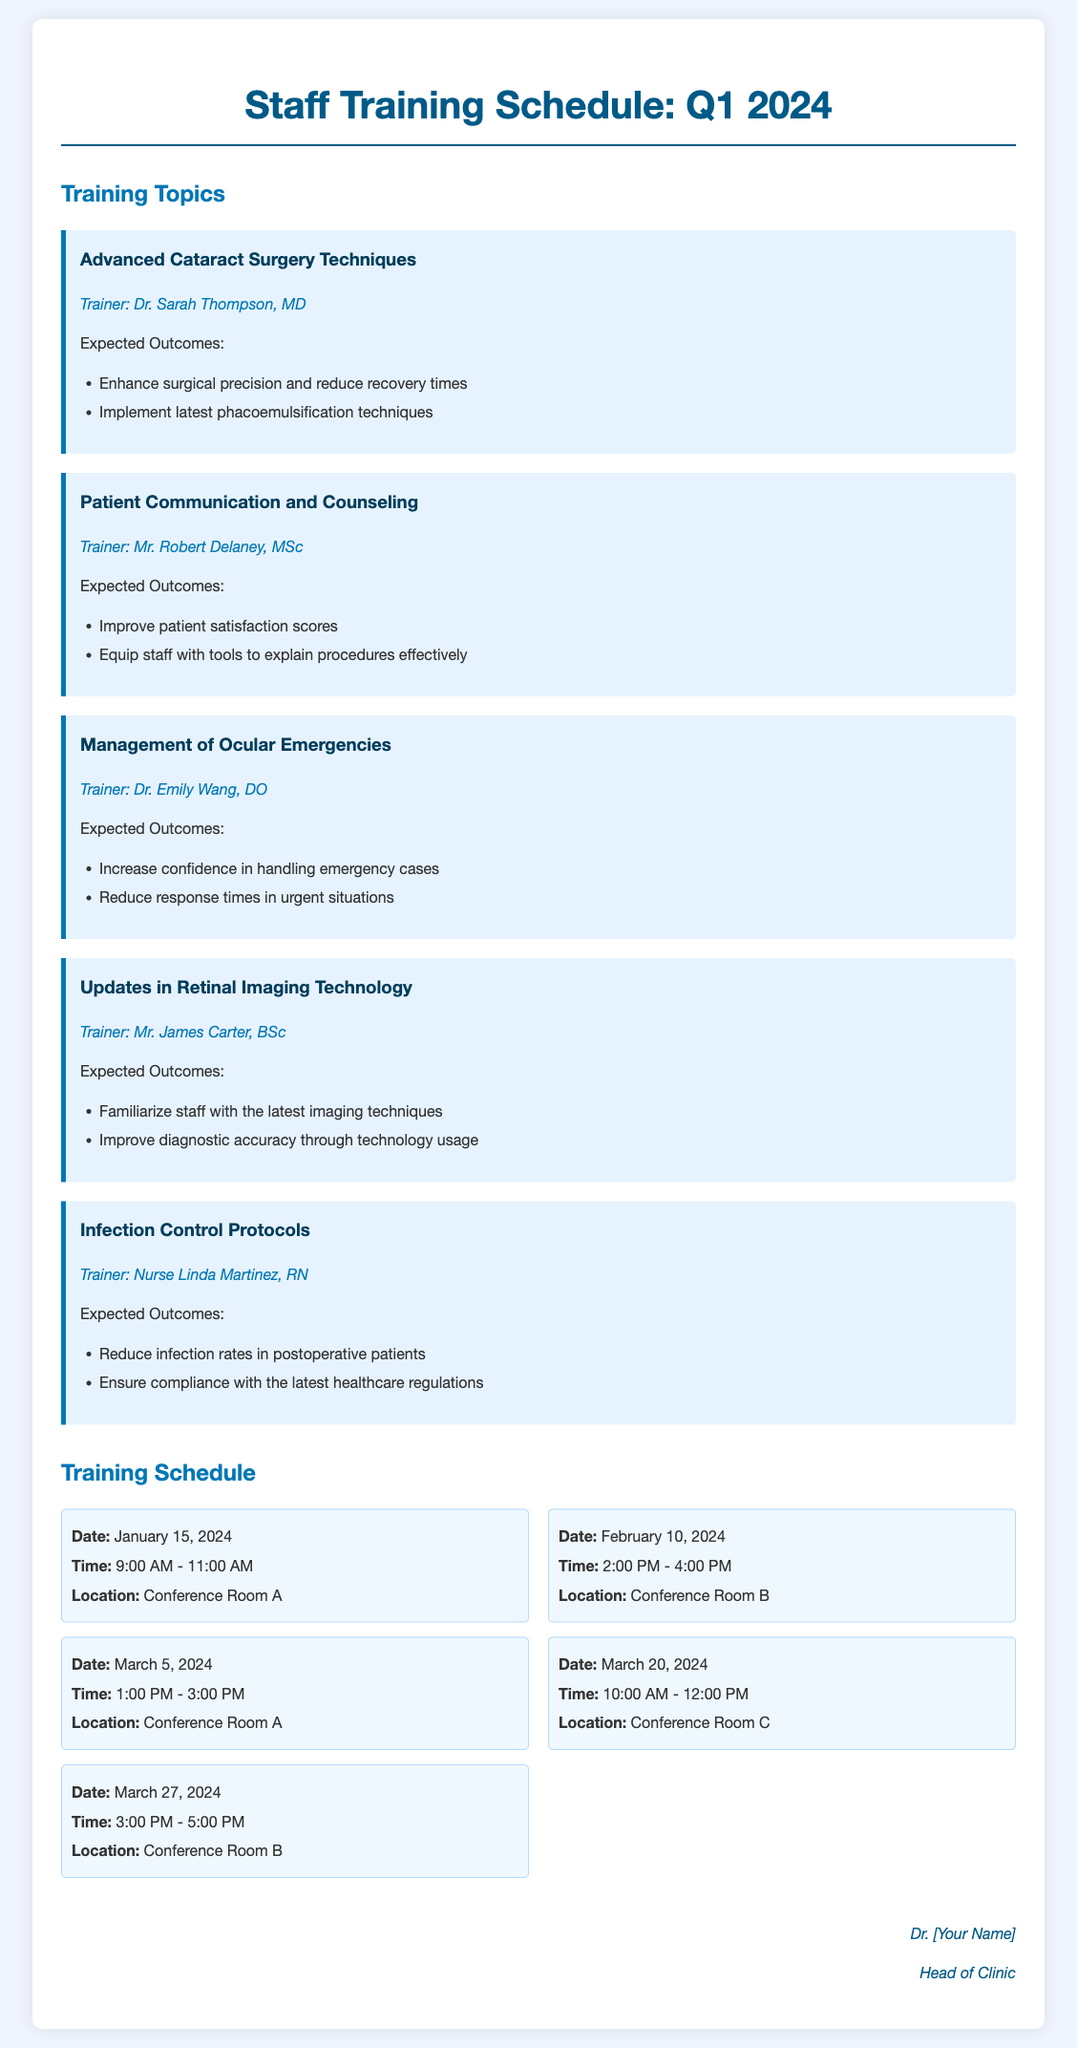What is the first training topic listed? The first training topic mentioned is "Advanced Cataract Surgery Techniques."
Answer: Advanced Cataract Surgery Techniques Who is the trainer for Infection Control Protocols? The trainer for Infection Control Protocols is Nurse Linda Martinez, RN.
Answer: Nurse Linda Martinez, RN What is the date of the session on Patient Communication and Counseling? The session on Patient Communication and Counseling is scheduled for February 10, 2024.
Answer: February 10, 2024 How many expected outcomes are listed for Management of Ocular Emergencies? There are two expected outcomes listed for Management of Ocular Emergencies.
Answer: 2 What time does the session on Updates in Retinal Imaging Technology start? The session on Updates in Retinal Imaging Technology starts at 1:00 PM.
Answer: 1:00 PM What is the main goal of the Advanced Cataract Surgery Techniques training? The main goal is to enhance surgical precision and reduce recovery times.
Answer: Enhance surgical precision and reduce recovery times What session is scheduled in Conference Room C? The session scheduled in Conference Room C is on March 20, 2024.
Answer: March 20, 2024 By how much time is the session on Infection Control Protocols shorter than the session on Management of Ocular Emergencies? The session on Infection Control Protocols is 1 hour shorter than the session on Management of Ocular Emergencies.
Answer: 1 hour shorter What is the location for the session on March 27, 2024? The location for the session on March 27, 2024, is Conference Room B.
Answer: Conference Room B 